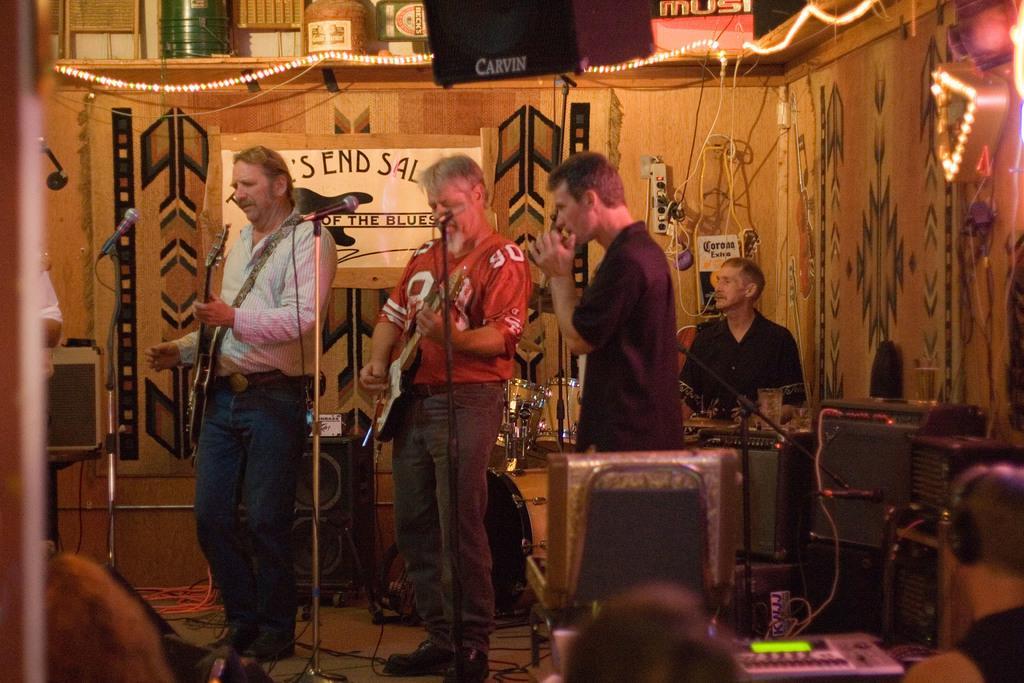Describe this image in one or two sentences. In this picture we can see few persons standing in front of a mike and playing musical instruments. Here we can see electronic devices, television and one man is sitting and playing musical instrument. On the background we can see boards, painting, lights. 